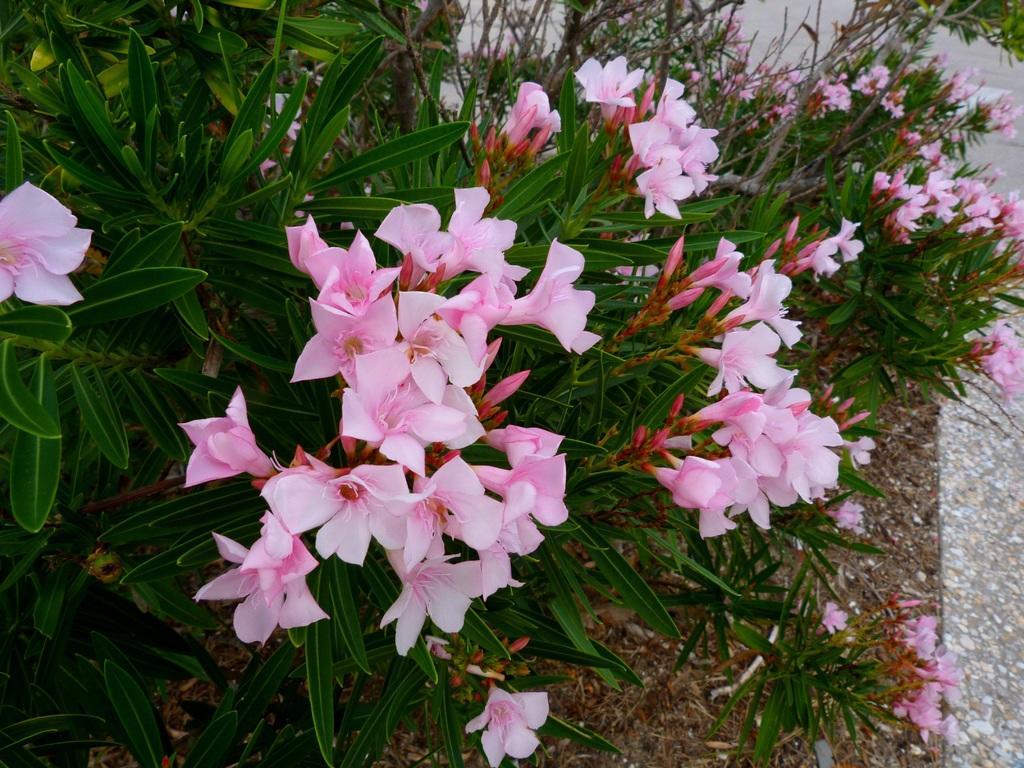Can you describe this image briefly? In this image I can see few flowers which are pink in color to the plants which are green in color. I can see the ground in the background. 